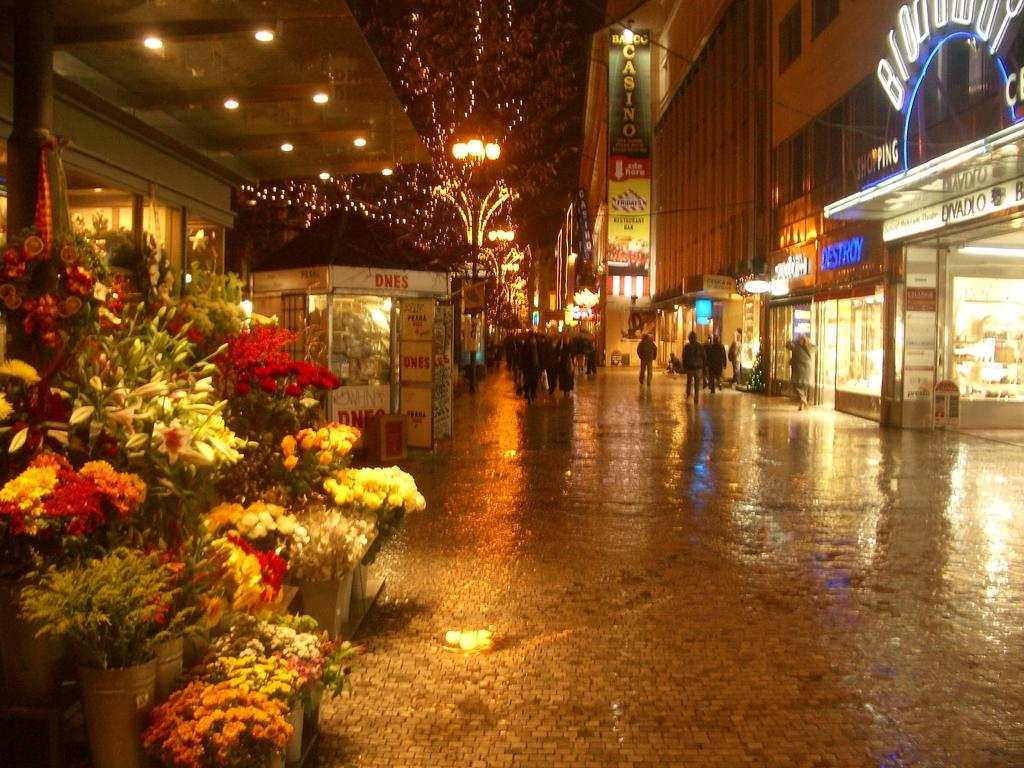What can be seen in the image that represents natural beauty? There are flower bouquets in the image. What is the main feature of the landscape in the image? There is a road in the image. What is happening on the road? There are people on the road. What can be seen in the image that provides illumination? There are lights visible in the image. What type of structures can be seen in the image? There are buildings in the image. What is the large sign in the image used for? There is a hoarding in the image, which is typically used for advertising. What are the smaller signs in the image used for? There are boards in the image, which may be used for directions, information, or advertising. What type of net is being used by the people on the road in the image? There is no net visible in the image, and the people on the road are not using any net. What color are the trousers worn by the people on the road in the image? The provided facts do not mention the color or type of clothing worn by the people on the road, so we cannot answer this question. 